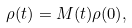Convert formula to latex. <formula><loc_0><loc_0><loc_500><loc_500>\rho ( t ) = M ( t ) \rho ( 0 ) ,</formula> 